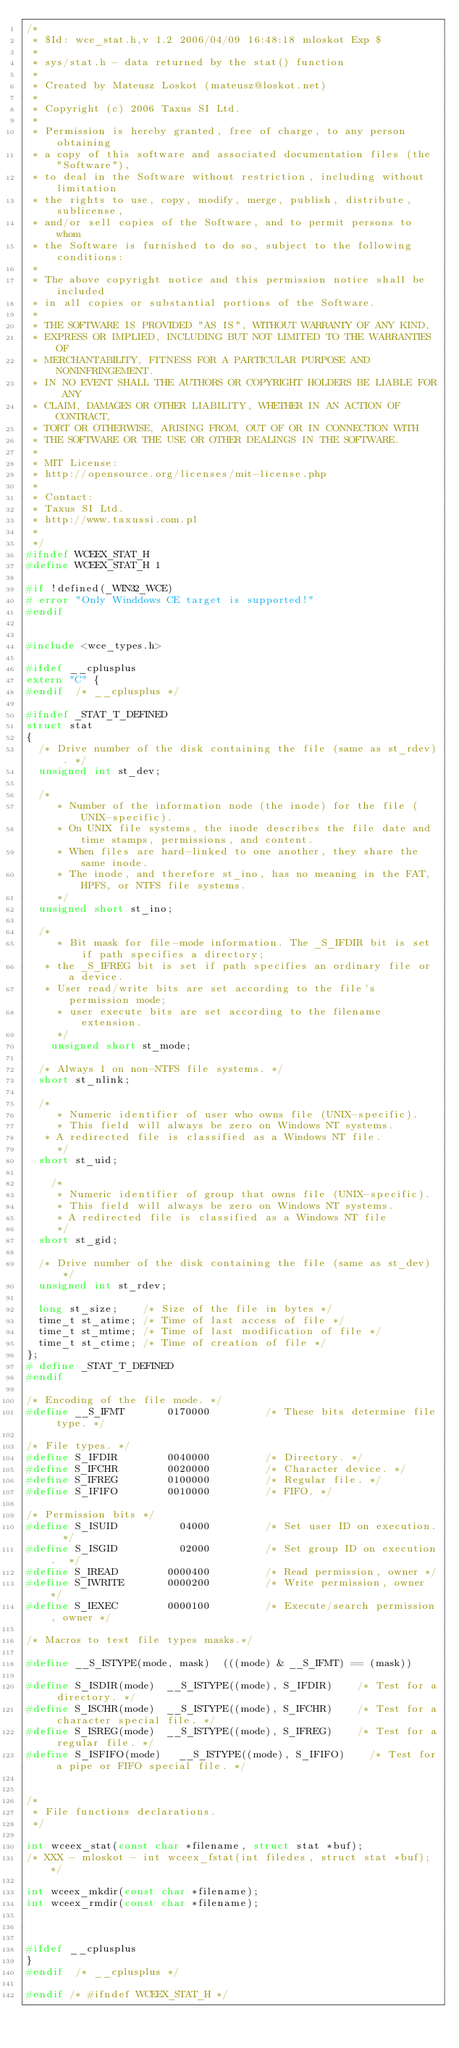Convert code to text. <code><loc_0><loc_0><loc_500><loc_500><_C_>/*
 * $Id: wce_stat.h,v 1.2 2006/04/09 16:48:18 mloskot Exp $
 *
 * sys/stat.h - data returned by the stat() function
 *
 * Created by Mateusz Loskot (mateusz@loskot.net)
 *
 * Copyright (c) 2006 Taxus SI Ltd.
 *
 * Permission is hereby granted, free of charge, to any person obtaining
 * a copy of this software and associated documentation files (the "Software"),
 * to deal in the Software without restriction, including without limitation 
 * the rights to use, copy, modify, merge, publish, distribute, sublicense,
 * and/or sell copies of the Software, and to permit persons to whom 
 * the Software is furnished to do so, subject to the following conditions:
 * 
 * The above copyright notice and this permission notice shall be included
 * in all copies or substantial portions of the Software.
 *
 * THE SOFTWARE IS PROVIDED "AS IS", WITHOUT WARRANTY OF ANY KIND,
 * EXPRESS OR IMPLIED, INCLUDING BUT NOT LIMITED TO THE WARRANTIES OF
 * MERCHANTABILITY, FITNESS FOR A PARTICULAR PURPOSE AND NONINFRINGEMENT.
 * IN NO EVENT SHALL THE AUTHORS OR COPYRIGHT HOLDERS BE LIABLE FOR ANY
 * CLAIM, DAMAGES OR OTHER LIABILITY, WHETHER IN AN ACTION OF CONTRACT,
 * TORT OR OTHERWISE, ARISING FROM, OUT OF OR IN CONNECTION WITH
 * THE SOFTWARE OR THE USE OR OTHER DEALINGS IN THE SOFTWARE.
 *
 * MIT License:
 * http://opensource.org/licenses/mit-license.php
 *
 * Contact:
 * Taxus SI Ltd.
 * http://www.taxussi.com.pl
 *
 */
#ifndef WCEEX_STAT_H
#define WCEEX_STAT_H 1

#if !defined(_WIN32_WCE)
# error "Only Winddows CE target is supported!"
#endif


#include <wce_types.h>

#ifdef __cplusplus
extern "C" {
#endif  /* __cplusplus */

#ifndef _STAT_T_DEFINED
struct stat
{
	/* Drive number of the disk containing the file (same as st_rdev). */
	unsigned int st_dev;

	/*
     * Number of the information node (the inode) for the file (UNIX-specific).
     * On UNIX file systems, the inode describes the file date and time stamps, permissions, and content.
     * When files are hard-linked to one another, they share the same inode. 
     * The inode, and therefore st_ino, has no meaning in the FAT, HPFS, or NTFS file systems.
     */
	unsigned short st_ino;

	/*
     * Bit mask for file-mode information. The _S_IFDIR bit is set if path specifies a directory;
	 * the _S_IFREG bit is set if path specifies an ordinary file or a device. 
	 * User read/write bits are set according to the file's permission mode;
     * user execute bits are set according to the filename extension.
     */
    unsigned short st_mode;

	/* Always 1 on non-NTFS file systems. */
	short st_nlink;

	/*
     * Numeric identifier of user who owns file (UNIX-specific).
     * This field will always be zero on Windows NT systems.
	 * A redirected file is classified as a Windows NT file.
     */
	short st_uid;
	
    /*
     * Numeric identifier of group that owns file (UNIX-specific).
     * This field will always be zero on Windows NT systems.
     * A redirected file is classified as a Windows NT file
     */
	short st_gid;

	/* Drive number of the disk containing the file (same as st_dev) */
	unsigned int st_rdev;

	long st_size;    /* Size of the file in bytes */
	time_t st_atime; /* Time of last access of file */
	time_t st_mtime; /* Time of last modification of file */
	time_t st_ctime; /* Time of creation of file */
};
# define _STAT_T_DEFINED
#endif

/* Encoding of the file mode. */
#define __S_IFMT       0170000         /* These bits determine file type. */

/* File types. */
#define S_IFDIR        0040000         /* Directory. */
#define S_IFCHR        0020000         /* Character device. */
#define S_IFREG        0100000         /* Regular file. */
#define S_IFIFO        0010000         /* FIFO. */

/* Permission bits */
#define	S_ISUID	         04000	       /* Set user ID on execution.  */
#define	S_ISGID	         02000	       /* Set group ID on execution.  */ 
#define S_IREAD        0000400         /* Read permission, owner */
#define S_IWRITE       0000200         /* Write permission, owner */
#define S_IEXEC        0000100         /* Execute/search permission, owner */

/* Macros to test file types masks.*/

#define	__S_ISTYPE(mode, mask)	(((mode) & __S_IFMT) == (mask))

#define	S_ISDIR(mode)	 __S_ISTYPE((mode), S_IFDIR)    /* Test for a directory. */
#define	S_ISCHR(mode)	 __S_ISTYPE((mode), S_IFCHR)    /* Test for a character special file. */
#define	S_ISREG(mode)	 __S_ISTYPE((mode), S_IFREG)    /* Test for a regular file. */
#define S_ISFIFO(mode)	 __S_ISTYPE((mode), S_IFIFO)    /* Test for a pipe or FIFO special file. */


/*
 * File functions declarations.
 */

int wceex_stat(const char *filename, struct stat *buf);
/* XXX - mloskot - int wceex_fstat(int filedes, struct stat *buf); */

int wceex_mkdir(const char *filename);
int wceex_rmdir(const char *filename);



#ifdef __cplusplus
}
#endif  /* __cplusplus */

#endif /* #ifndef WCEEX_STAT_H */
</code> 